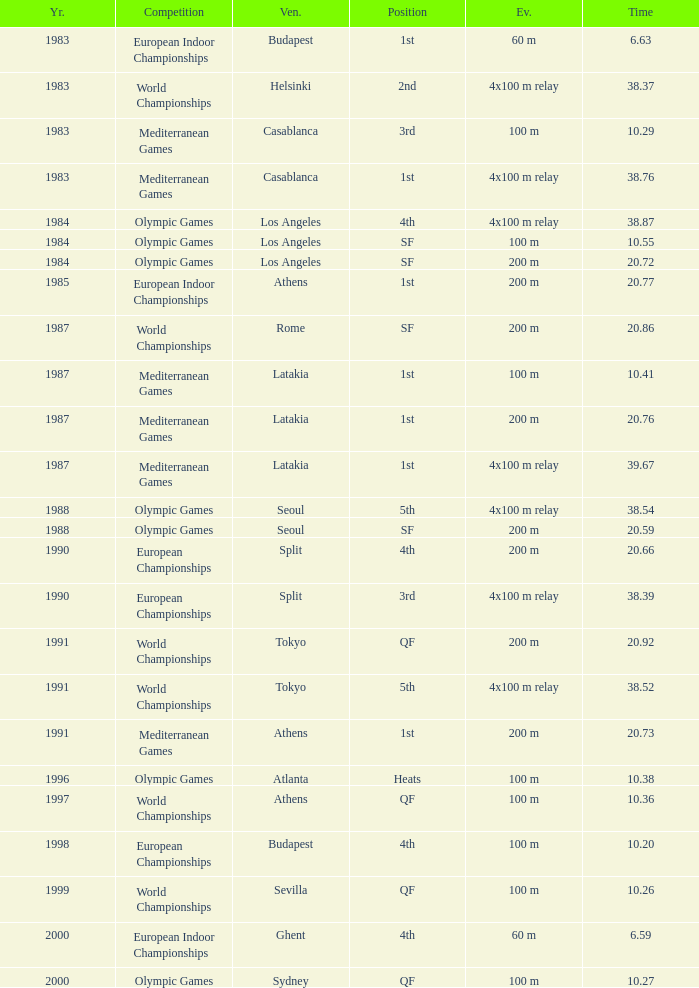What is the greatest Time with a Year of 1991, and Event of 4x100 m relay? 38.52. 